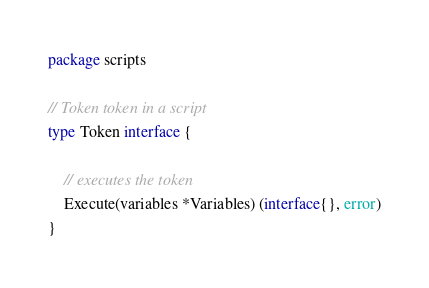<code> <loc_0><loc_0><loc_500><loc_500><_Go_>package scripts

// Token token in a script
type Token interface {

	// executes the token
	Execute(variables *Variables) (interface{}, error)
}
</code> 